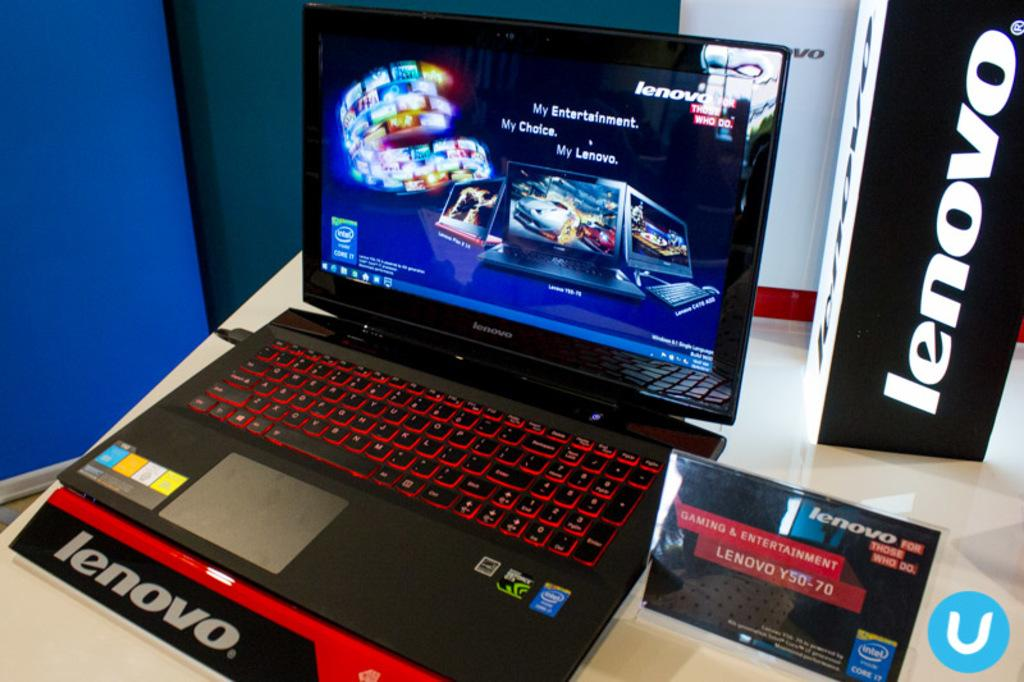<image>
Provide a brief description of the given image. A black laptop computer open made by Lenovo 